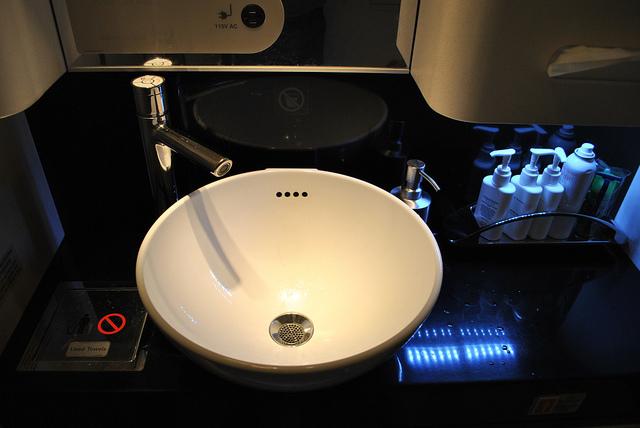Where are the lotions?
Give a very brief answer. On counter. What color is the faucet?
Write a very short answer. Silver. Where is the faucet?
Concise answer only. Above sink. 